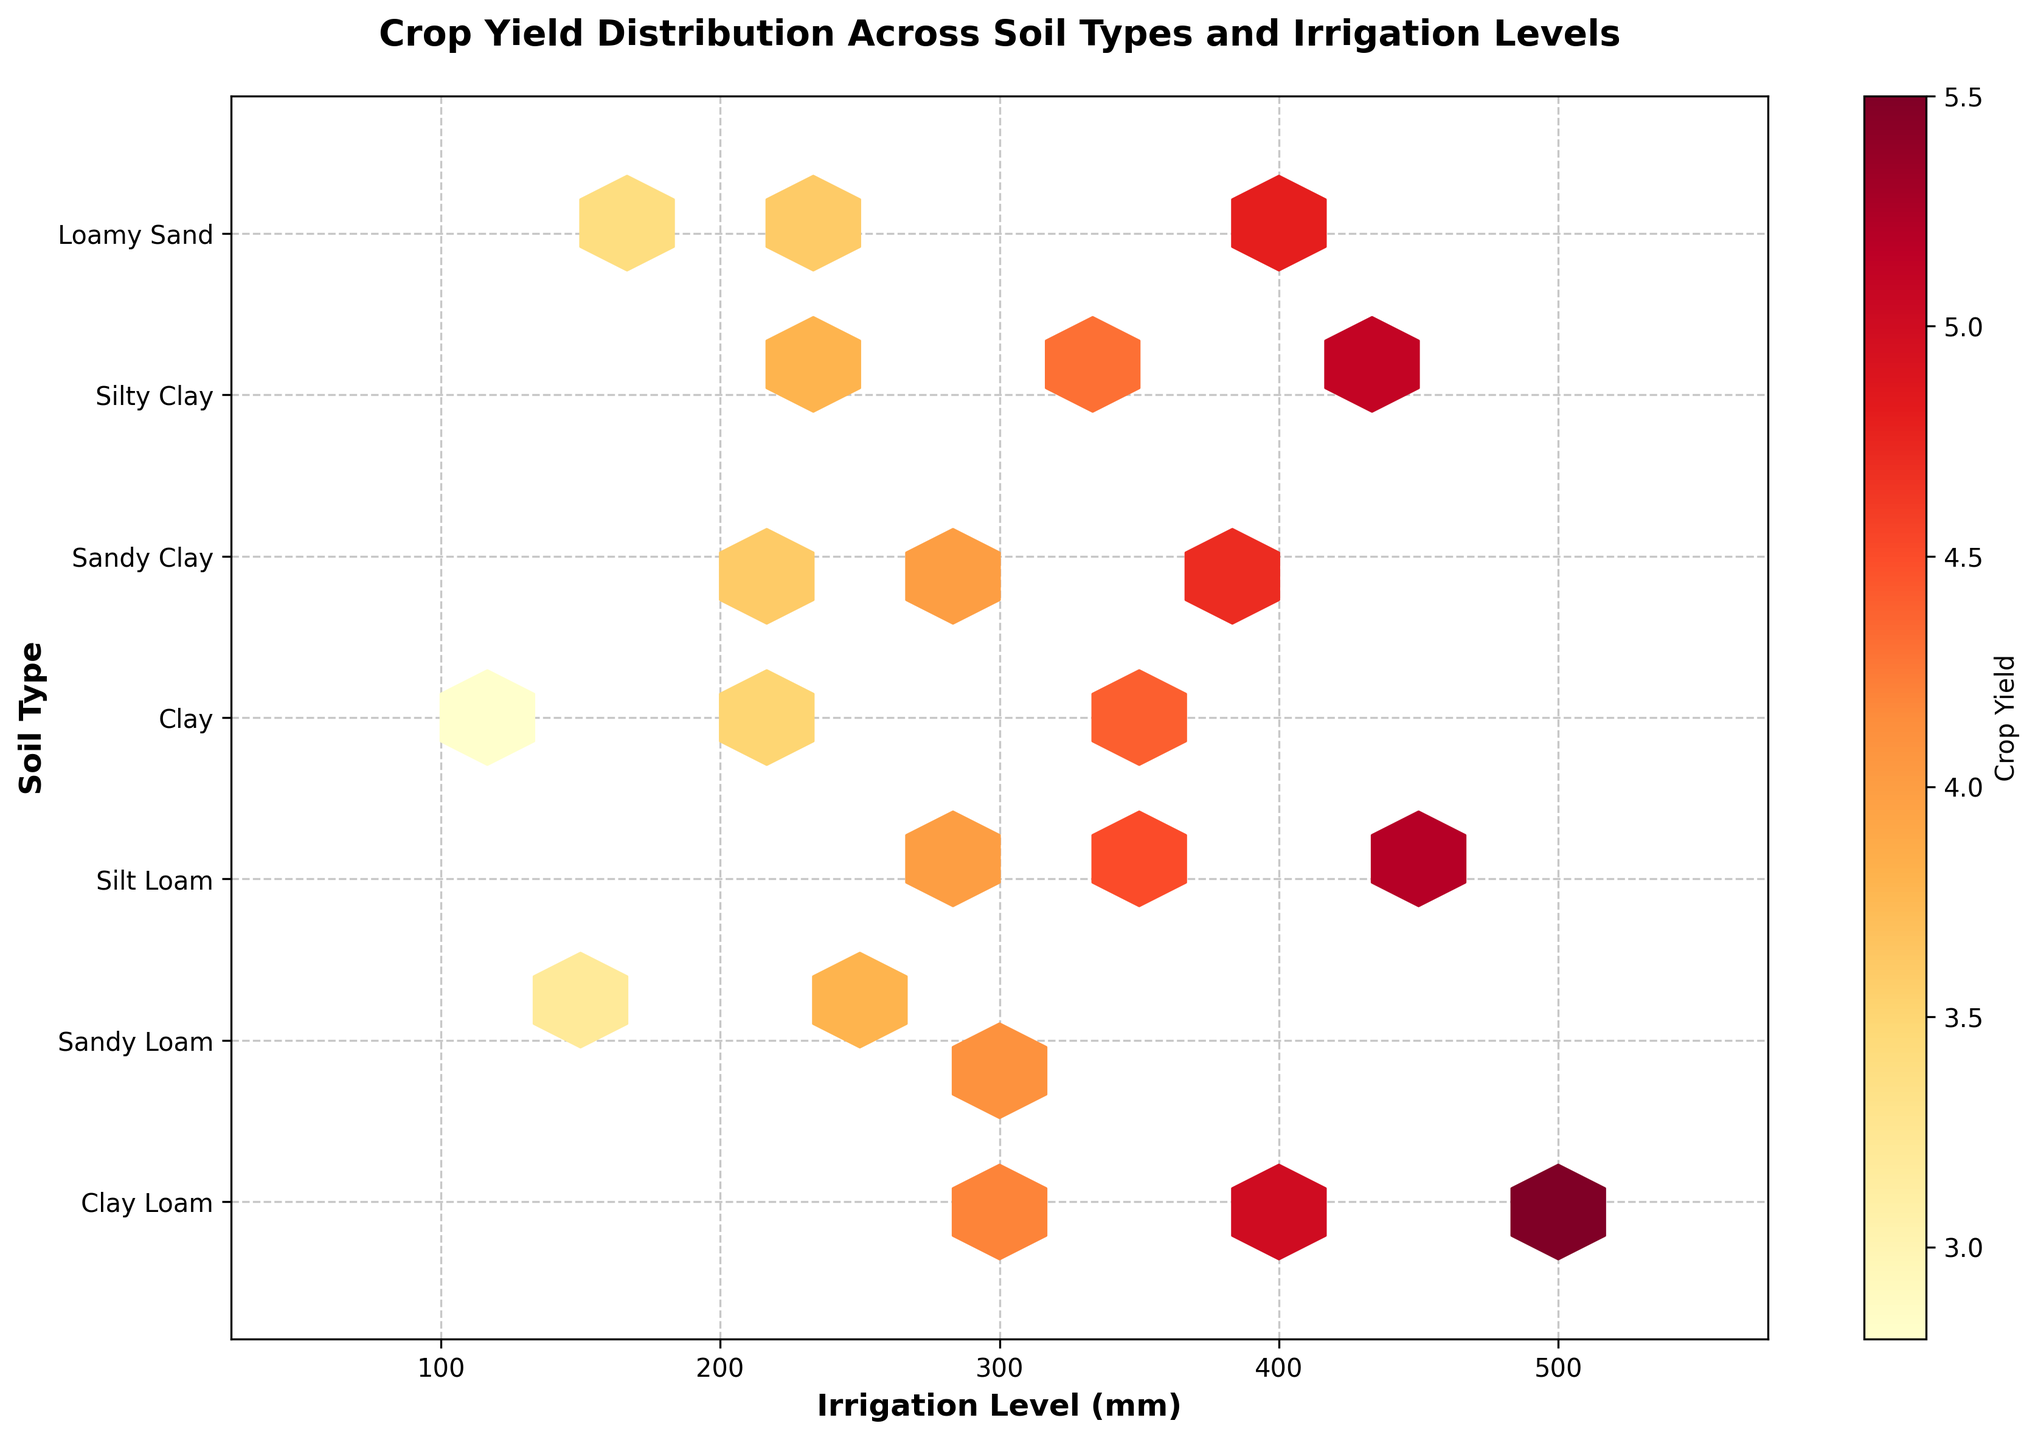What is the title of the plot? The title of a plot is usually located at the top center of the figure. In this hexbin plot, the title reads "Crop Yield Distribution Across Soil Types and Irrigation Levels".
Answer: Crop Yield Distribution Across Soil Types and Irrigation Levels How many unique soil types are represented in the plot? The soil types are listed along the y-axis, and each unique soil type is labeled. By counting the labels, we find there are 7 unique soil types.
Answer: 7 Which soil type appears at the top of the y-axis? The y-axis displays soil types from top to bottom. Looking at the topmost label, we see "Clay Loam".
Answer: Clay Loam What is the color used to represent the highest crop yield in the plot? The colorbar on the right side of the plot indicates the crop yield values associated with different colors. The highest value is represented by the darkest/red color in the "YlOrRd" colormap.
Answer: Dark Red Which irrigation level range shows data points across all soil types? By examining the x-axis (irrigation level) and checking where data points are present in all soil types, we see that the range from 200 mm to 400 mm covers all soil types.
Answer: 200 mm to 400 mm Which soil type tends to have higher crop yields with increased irrigation levels? Observing the color intensities across different soil types and irrigation levels, "Silt Loam" shows higher crop yields as the irrigation level increases. This is indicated by dark/red hexagons at higher irrigation values.
Answer: Silt Loam Compare the crop yields of "Sandy Loam" at irrigation levels 300 mm and 150 mm. Which has higher yields? The hexbin plot shows darker hexagons for higher yields. For "Sandy Loam" at 300 mm, the color is darker compared to 150 mm, indicating higher yields at 300 mm.
Answer: 300 mm What overall pattern can be observed about the relationship between irrigation level and crop yield? The plot shows a general trend where increases in irrigation levels (represented on the x-axis) are associated with higher crop yields (darker hexagons indicate higher crop yields).
Answer: Higher irrigation levels generally lead to higher crop yields For "Clay" soil type, at which irrigation level is the crop yield the lowest, and what color represents it? Checking "Clay" on the y-axis and finding the lightest hexagon, the lowest crop yield is at 100 mm irrigation level and is represented by a lighter yellow color.
Answer: 100 mm, lighter yellow Which soil type has the widest range of irrigation levels represented in the data points? By scanning the x-axis range for each soil type, "Clay Loam" displays the widest range, covering 300 mm, 400 mm, and 500 mm.
Answer: Clay Loam 